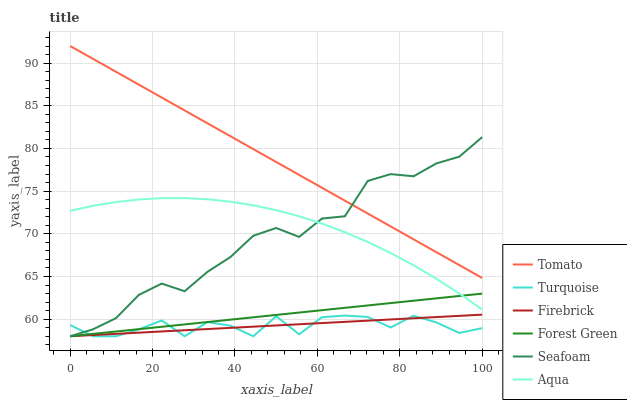Does Turquoise have the minimum area under the curve?
Answer yes or no. Yes. Does Tomato have the maximum area under the curve?
Answer yes or no. Yes. Does Firebrick have the minimum area under the curve?
Answer yes or no. No. Does Firebrick have the maximum area under the curve?
Answer yes or no. No. Is Firebrick the smoothest?
Answer yes or no. Yes. Is Turquoise the roughest?
Answer yes or no. Yes. Is Turquoise the smoothest?
Answer yes or no. No. Is Firebrick the roughest?
Answer yes or no. No. Does Turquoise have the lowest value?
Answer yes or no. Yes. Does Aqua have the lowest value?
Answer yes or no. No. Does Tomato have the highest value?
Answer yes or no. Yes. Does Firebrick have the highest value?
Answer yes or no. No. Is Firebrick less than Tomato?
Answer yes or no. Yes. Is Tomato greater than Turquoise?
Answer yes or no. Yes. Does Forest Green intersect Firebrick?
Answer yes or no. Yes. Is Forest Green less than Firebrick?
Answer yes or no. No. Is Forest Green greater than Firebrick?
Answer yes or no. No. Does Firebrick intersect Tomato?
Answer yes or no. No. 